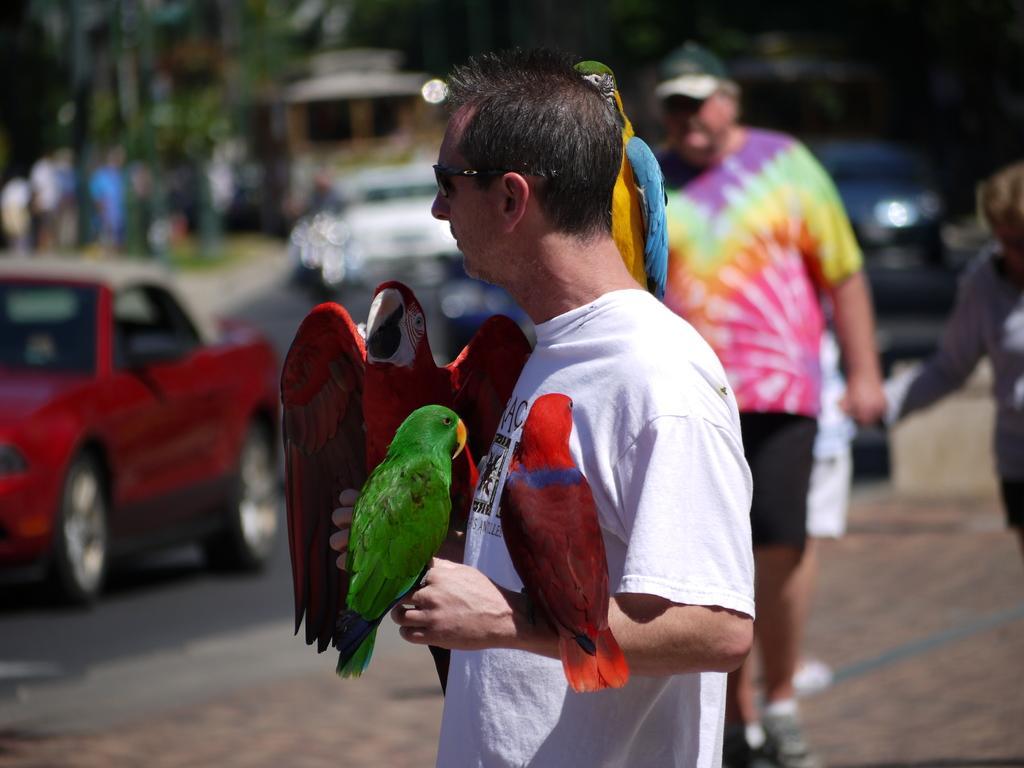Describe this image in one or two sentences. In this picture we can see a man standing in the front, we can see four parrots here, in the background there are some cars traveling on the road, we can see trees here. 